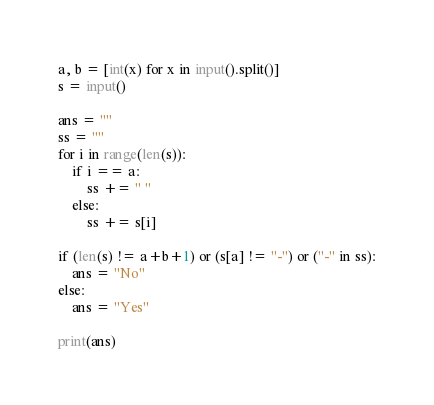<code> <loc_0><loc_0><loc_500><loc_500><_Python_>a, b = [int(x) for x in input().split()]
s = input()

ans = ""
ss = ""
for i in range(len(s)):
    if i == a:
        ss += " "
    else:
        ss += s[i]    

if (len(s) != a+b+1) or (s[a] != "-") or ("-" in ss):
    ans = "No"
else:
    ans = "Yes"

print(ans)</code> 